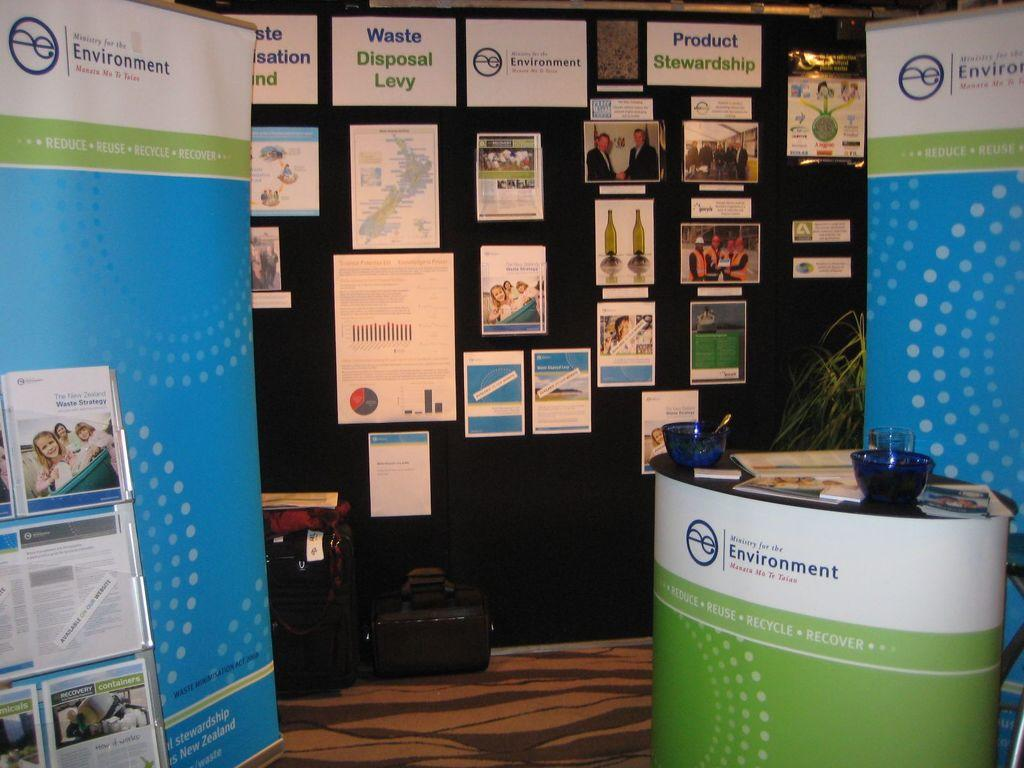<image>
Write a terse but informative summary of the picture. Ministry for Environment office space headquarters waiting area. 